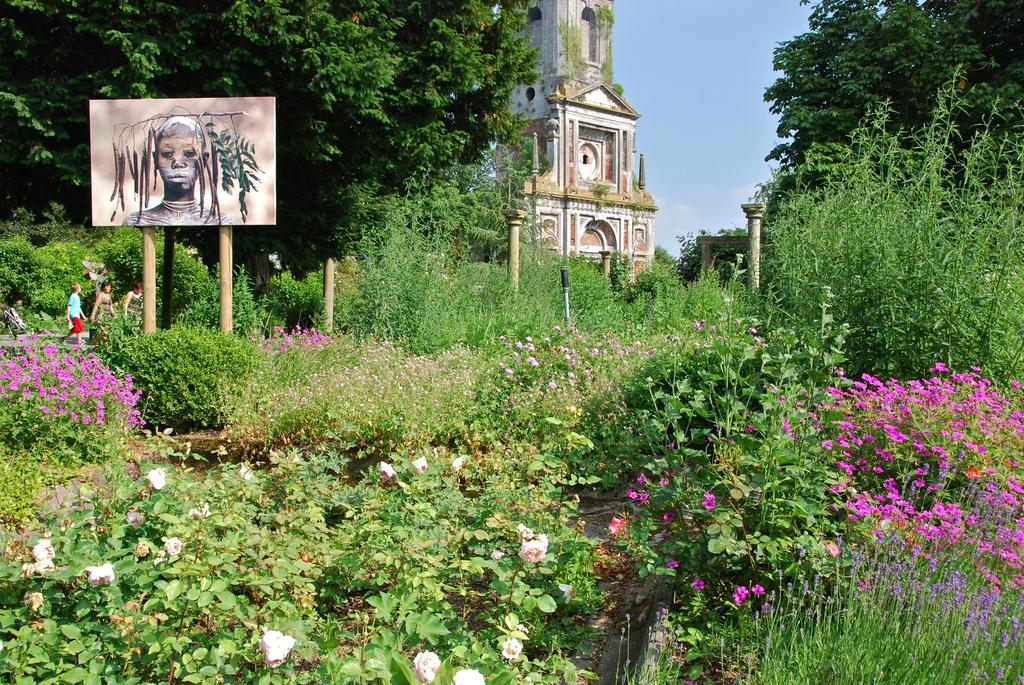What is located on the left side of the image? There is an art piece on the left side of the image. What type of plants can be seen in the image? There are flower plants in the image. What can be seen in the middle of the image? There appears to be a monument in the middle of the image. What language is spoken by the flower plants in the image? Flower plants do not speak any language, as they are inanimate objects. 